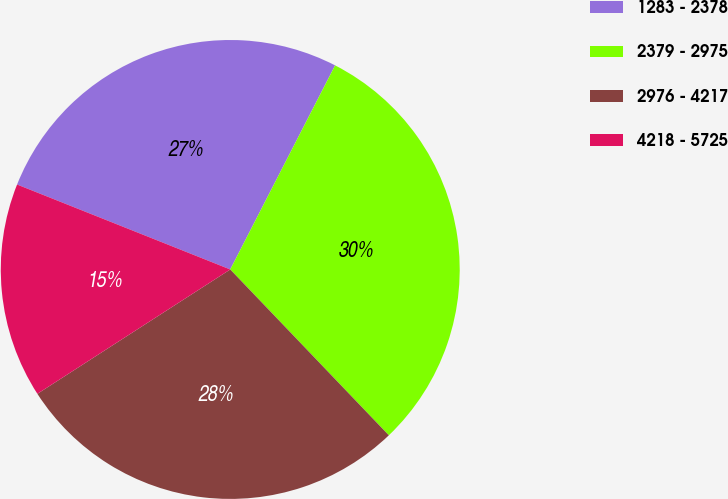Convert chart. <chart><loc_0><loc_0><loc_500><loc_500><pie_chart><fcel>1283 - 2378<fcel>2379 - 2975<fcel>2976 - 4217<fcel>4218 - 5725<nl><fcel>26.52%<fcel>30.3%<fcel>28.03%<fcel>15.15%<nl></chart> 